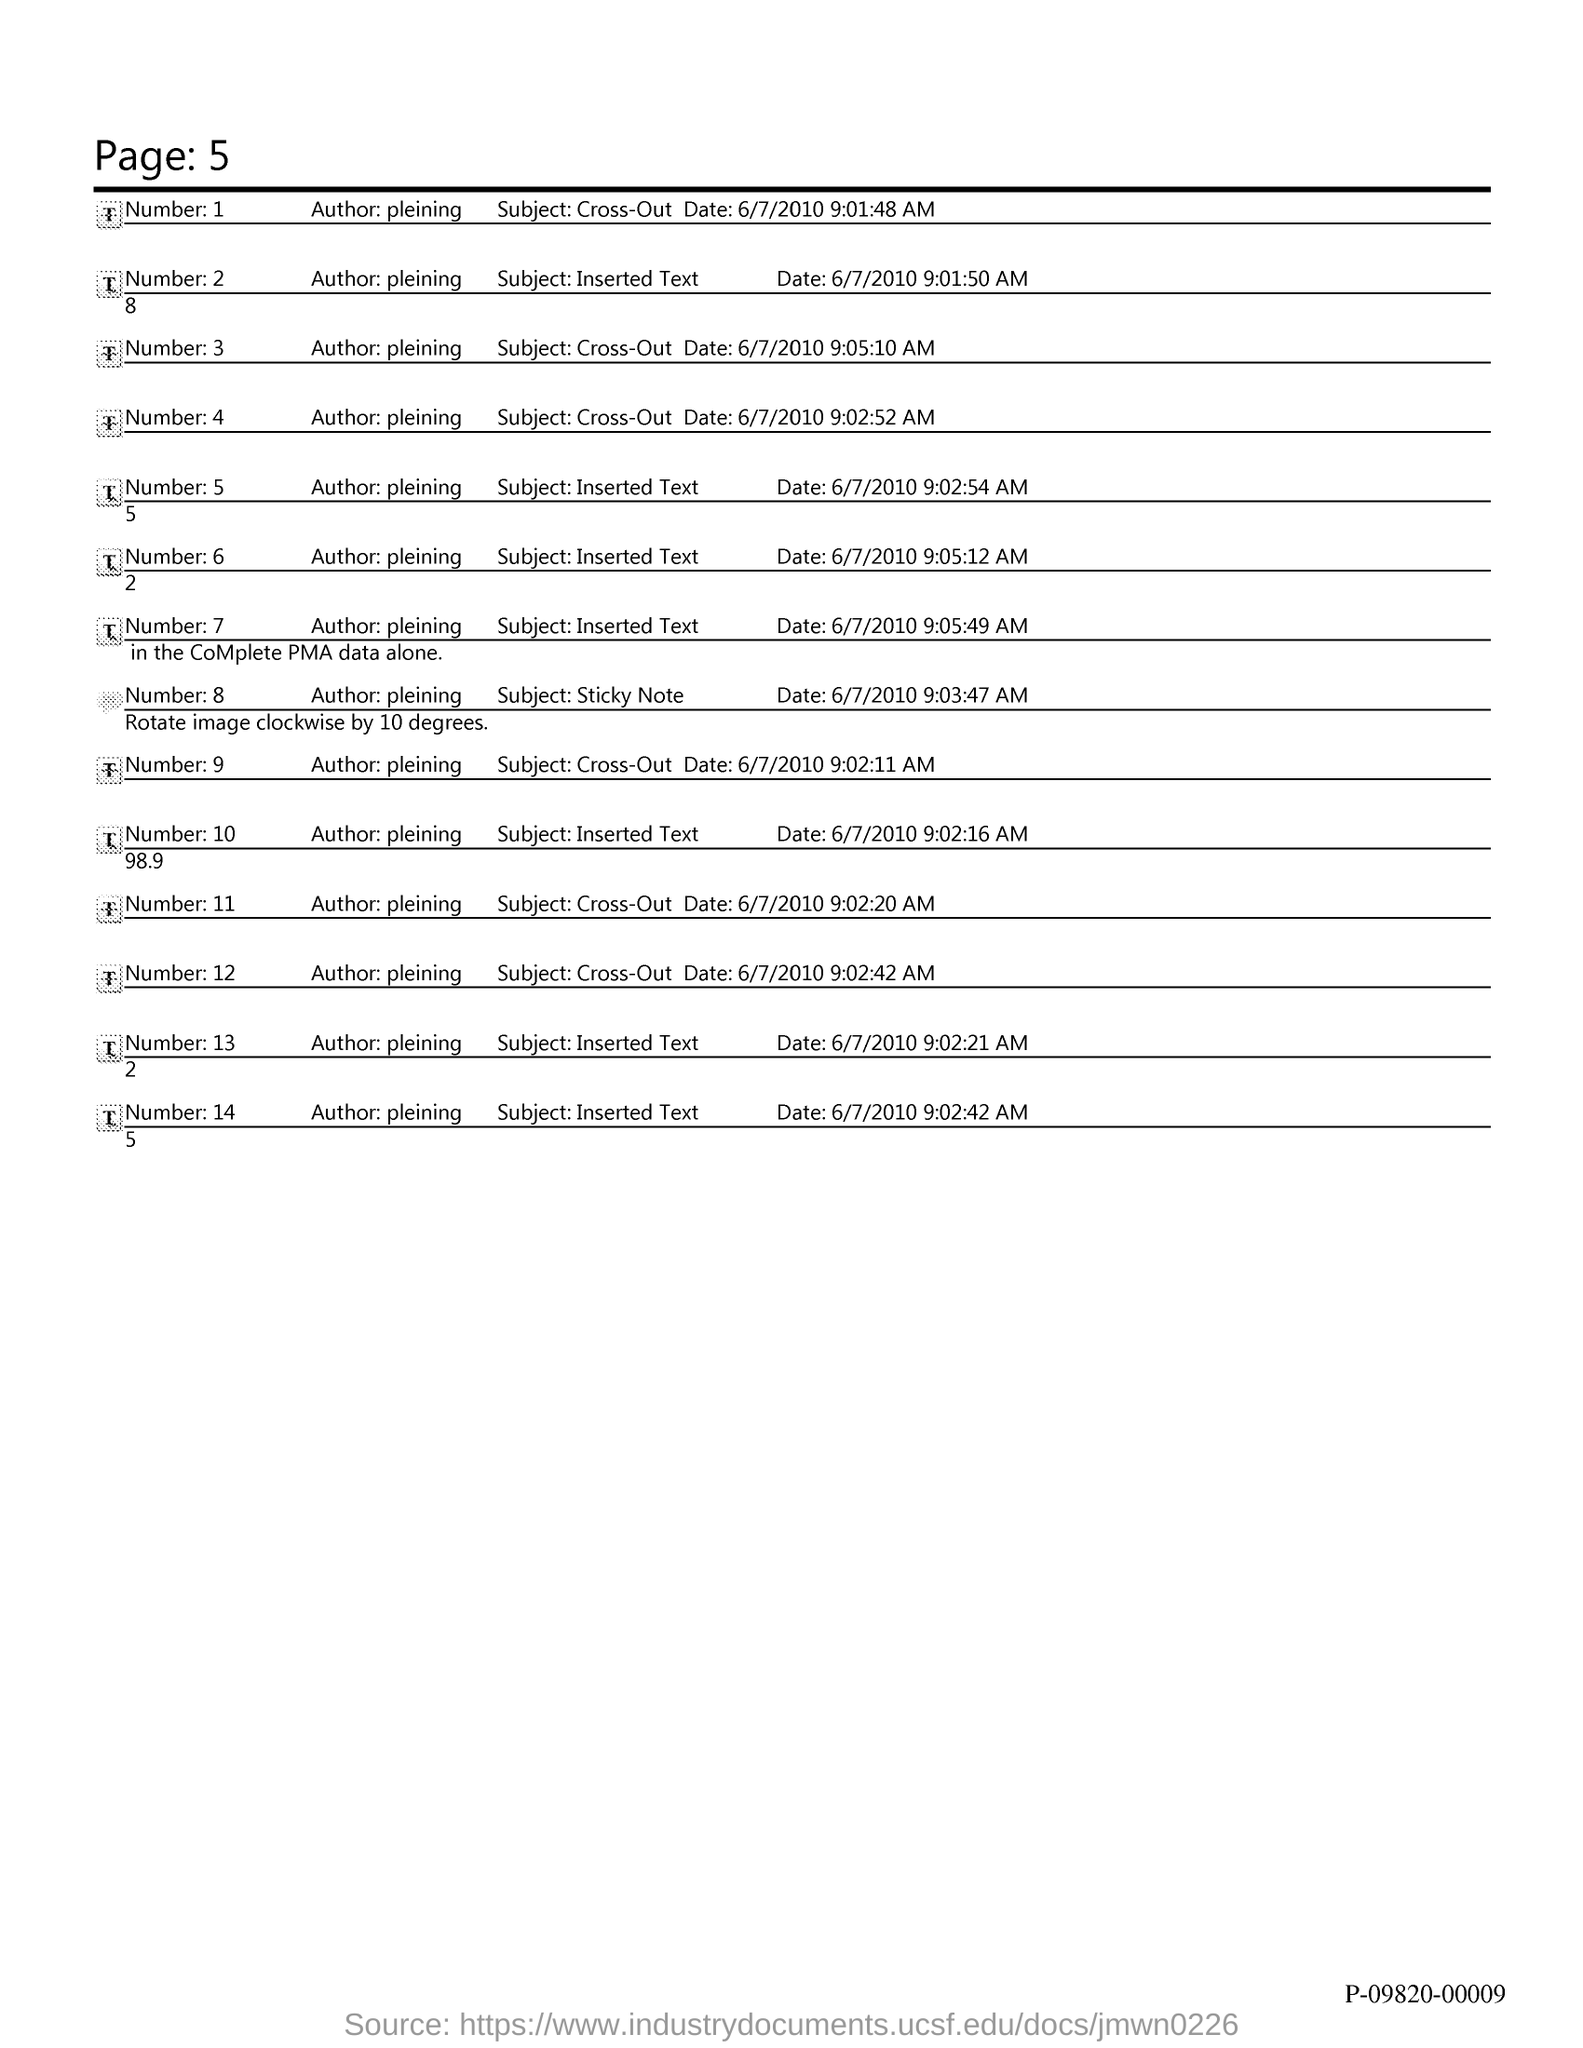Specify some key components in this picture. The page number is 5, as declared. 